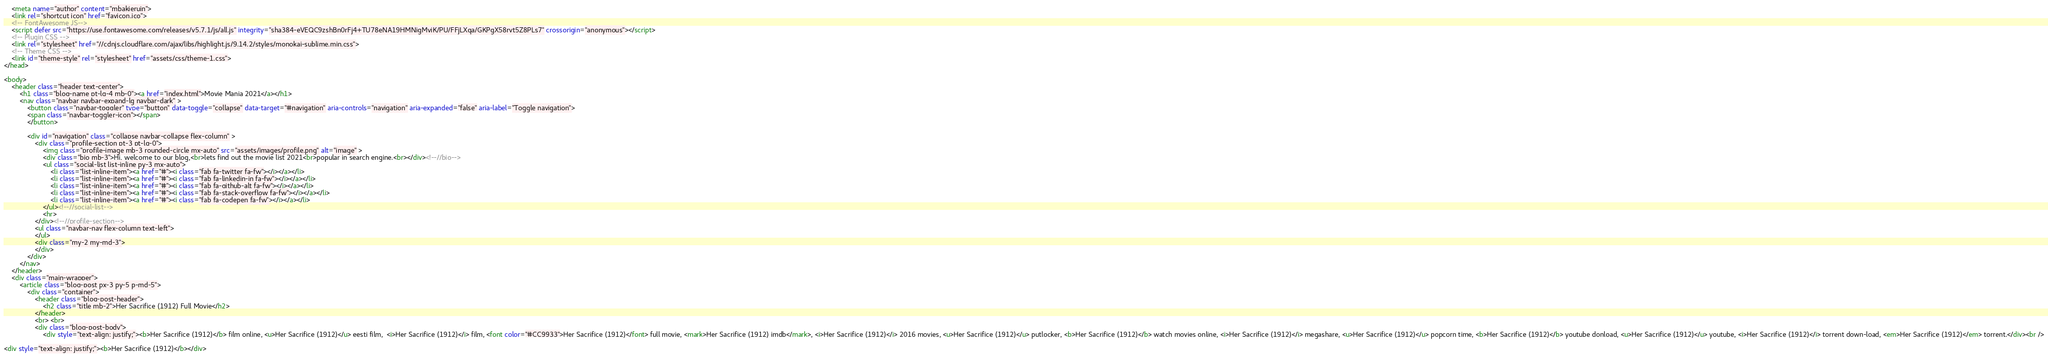<code> <loc_0><loc_0><loc_500><loc_500><_HTML_>    <meta name="author" content="mbakjeruin">    
    <link rel="shortcut icon" href="favicon.ico"> 
    <!-- FontAwesome JS-->
    <script defer src="https://use.fontawesome.com/releases/v5.7.1/js/all.js" integrity="sha384-eVEQC9zshBn0rFj4+TU78eNA19HMNigMviK/PU/FFjLXqa/GKPgX58rvt5Z8PLs7" crossorigin="anonymous"></script>
    <!-- Plugin CSS -->
    <link rel="stylesheet" href="//cdnjs.cloudflare.com/ajax/libs/highlight.js/9.14.2/styles/monokai-sublime.min.css">
    <!-- Theme CSS -->  
    <link id="theme-style" rel="stylesheet" href="assets/css/theme-1.css">
</head> 

<body>
    <header class="header text-center">	    
	    <h1 class="blog-name pt-lg-4 mb-0"><a href="index.html">Movie Mania 2021</a></h1>
	    <nav class="navbar navbar-expand-lg navbar-dark" >
			<button class="navbar-toggler" type="button" data-toggle="collapse" data-target="#navigation" aria-controls="navigation" aria-expanded="false" aria-label="Toggle navigation">
			<span class="navbar-toggler-icon"></span>
			</button>

			<div id="navigation" class="collapse navbar-collapse flex-column" >
				<div class="profile-section pt-3 pt-lg-0">
				    <img class="profile-image mb-3 rounded-circle mx-auto" src="assets/images/profile.png" alt="image" >			
					<div class="bio mb-3">Hi, welcome to our blog,<br>lets find out the movie list 2021<br>popular in search engine.<br></div><!--//bio-->
					<ul class="social-list list-inline py-3 mx-auto">
			            <li class="list-inline-item"><a href="#"><i class="fab fa-twitter fa-fw"></i></a></li>
			            <li class="list-inline-item"><a href="#"><i class="fab fa-linkedin-in fa-fw"></i></a></li>
			            <li class="list-inline-item"><a href="#"><i class="fab fa-github-alt fa-fw"></i></a></li>
			            <li class="list-inline-item"><a href="#"><i class="fab fa-stack-overflow fa-fw"></i></a></li>
			            <li class="list-inline-item"><a href="#"><i class="fab fa-codepen fa-fw"></i></a></li>
			        </ul><!--//social-list-->
			        <hr> 
				</div><!--//profile-section-->
				<ul class="navbar-nav flex-column text-left">
				</ul>
				<div class="my-2 my-md-3">
				</div>
			</div>
		</nav>
    </header>
    <div class="main-wrapper">
	    <article class="blog-post px-3 py-5 p-md-5">
		    <div class="container">
			    <header class="blog-post-header">
				    <h2 class="title mb-2">Her Sacrifice (1912) Full Movie</h2>			  
			    </header>
			    <br> <br>
			    <div class="blog-post-body">
				    <div style="text-align: justify;"><b>Her Sacrifice (1912)</b> film online, <u>Her Sacrifice (1912)</u> eesti film,  <i>Her Sacrifice (1912)</i> film, <font color="#CC9933">Her Sacrifice (1912)</font> full movie, <mark>Her Sacrifice (1912) imdb</mark>, <i>Her Sacrifice (1912)</i> 2016 movies, <u>Her Sacrifice (1912)</u> putlocker, <b>Her Sacrifice (1912)</b> watch movies online, <i>Her Sacrifice (1912)</i> megashare, <u>Her Sacrifice (1912)</u> popcorn time, <b>Her Sacrifice (1912)</b> youtube donload, <u>Her Sacrifice (1912)</u> youtube, <i>Her Sacrifice (1912)</i> torrent down-load, <em>Her Sacrifice (1912)</em> torrent.</div><br />

<div style="text-align: justify;"><b>Her Sacrifice (1912)</b></div></code> 